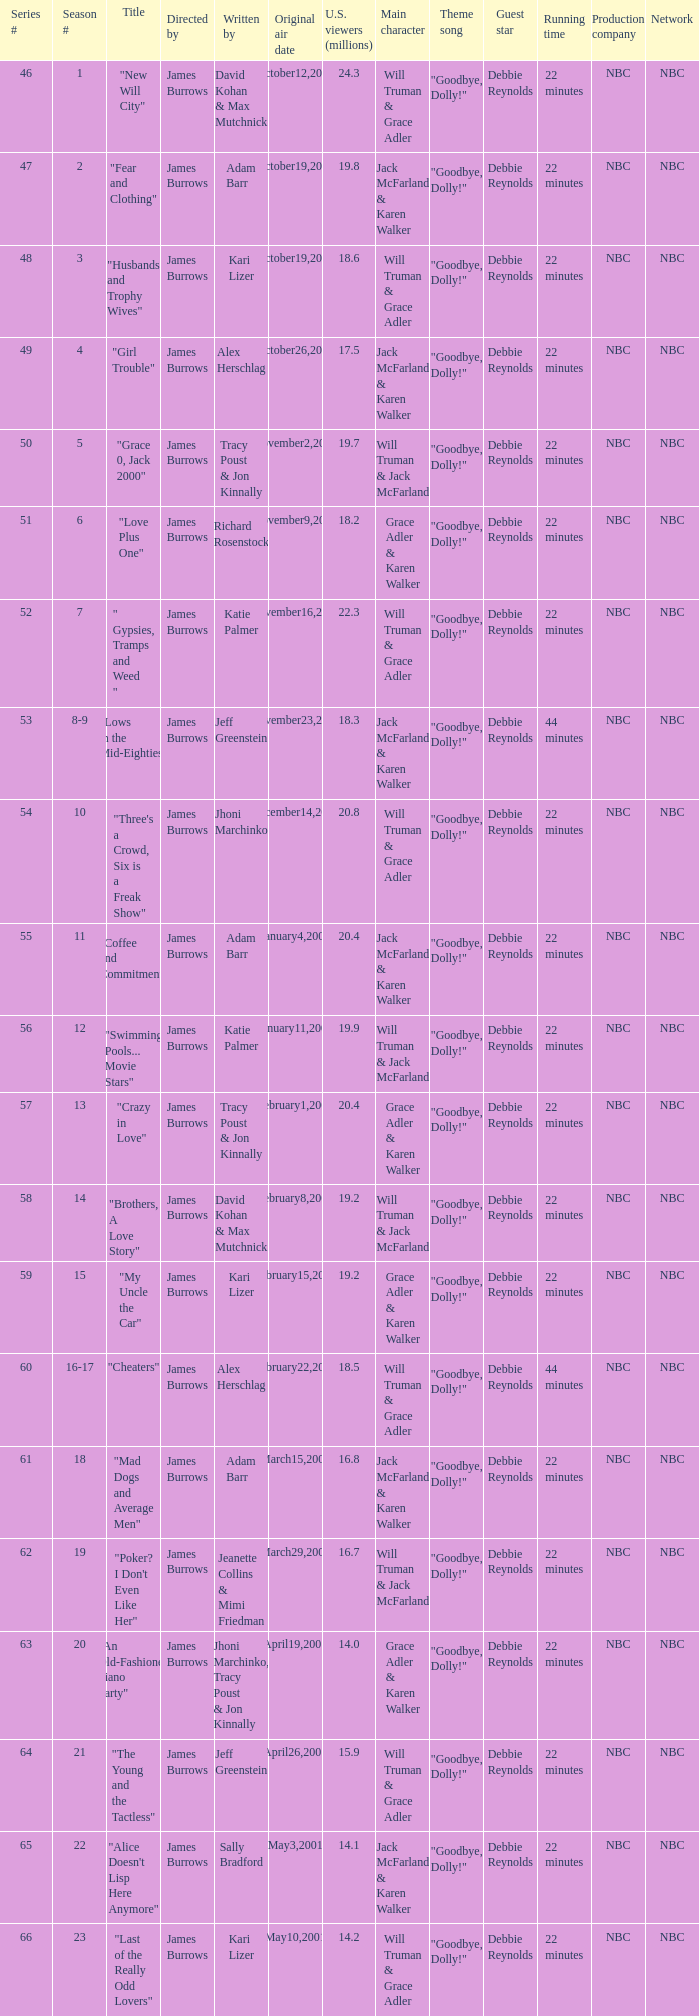Who wrote the episode titled "An Old-fashioned Piano Party"? Jhoni Marchinko, Tracy Poust & Jon Kinnally. 